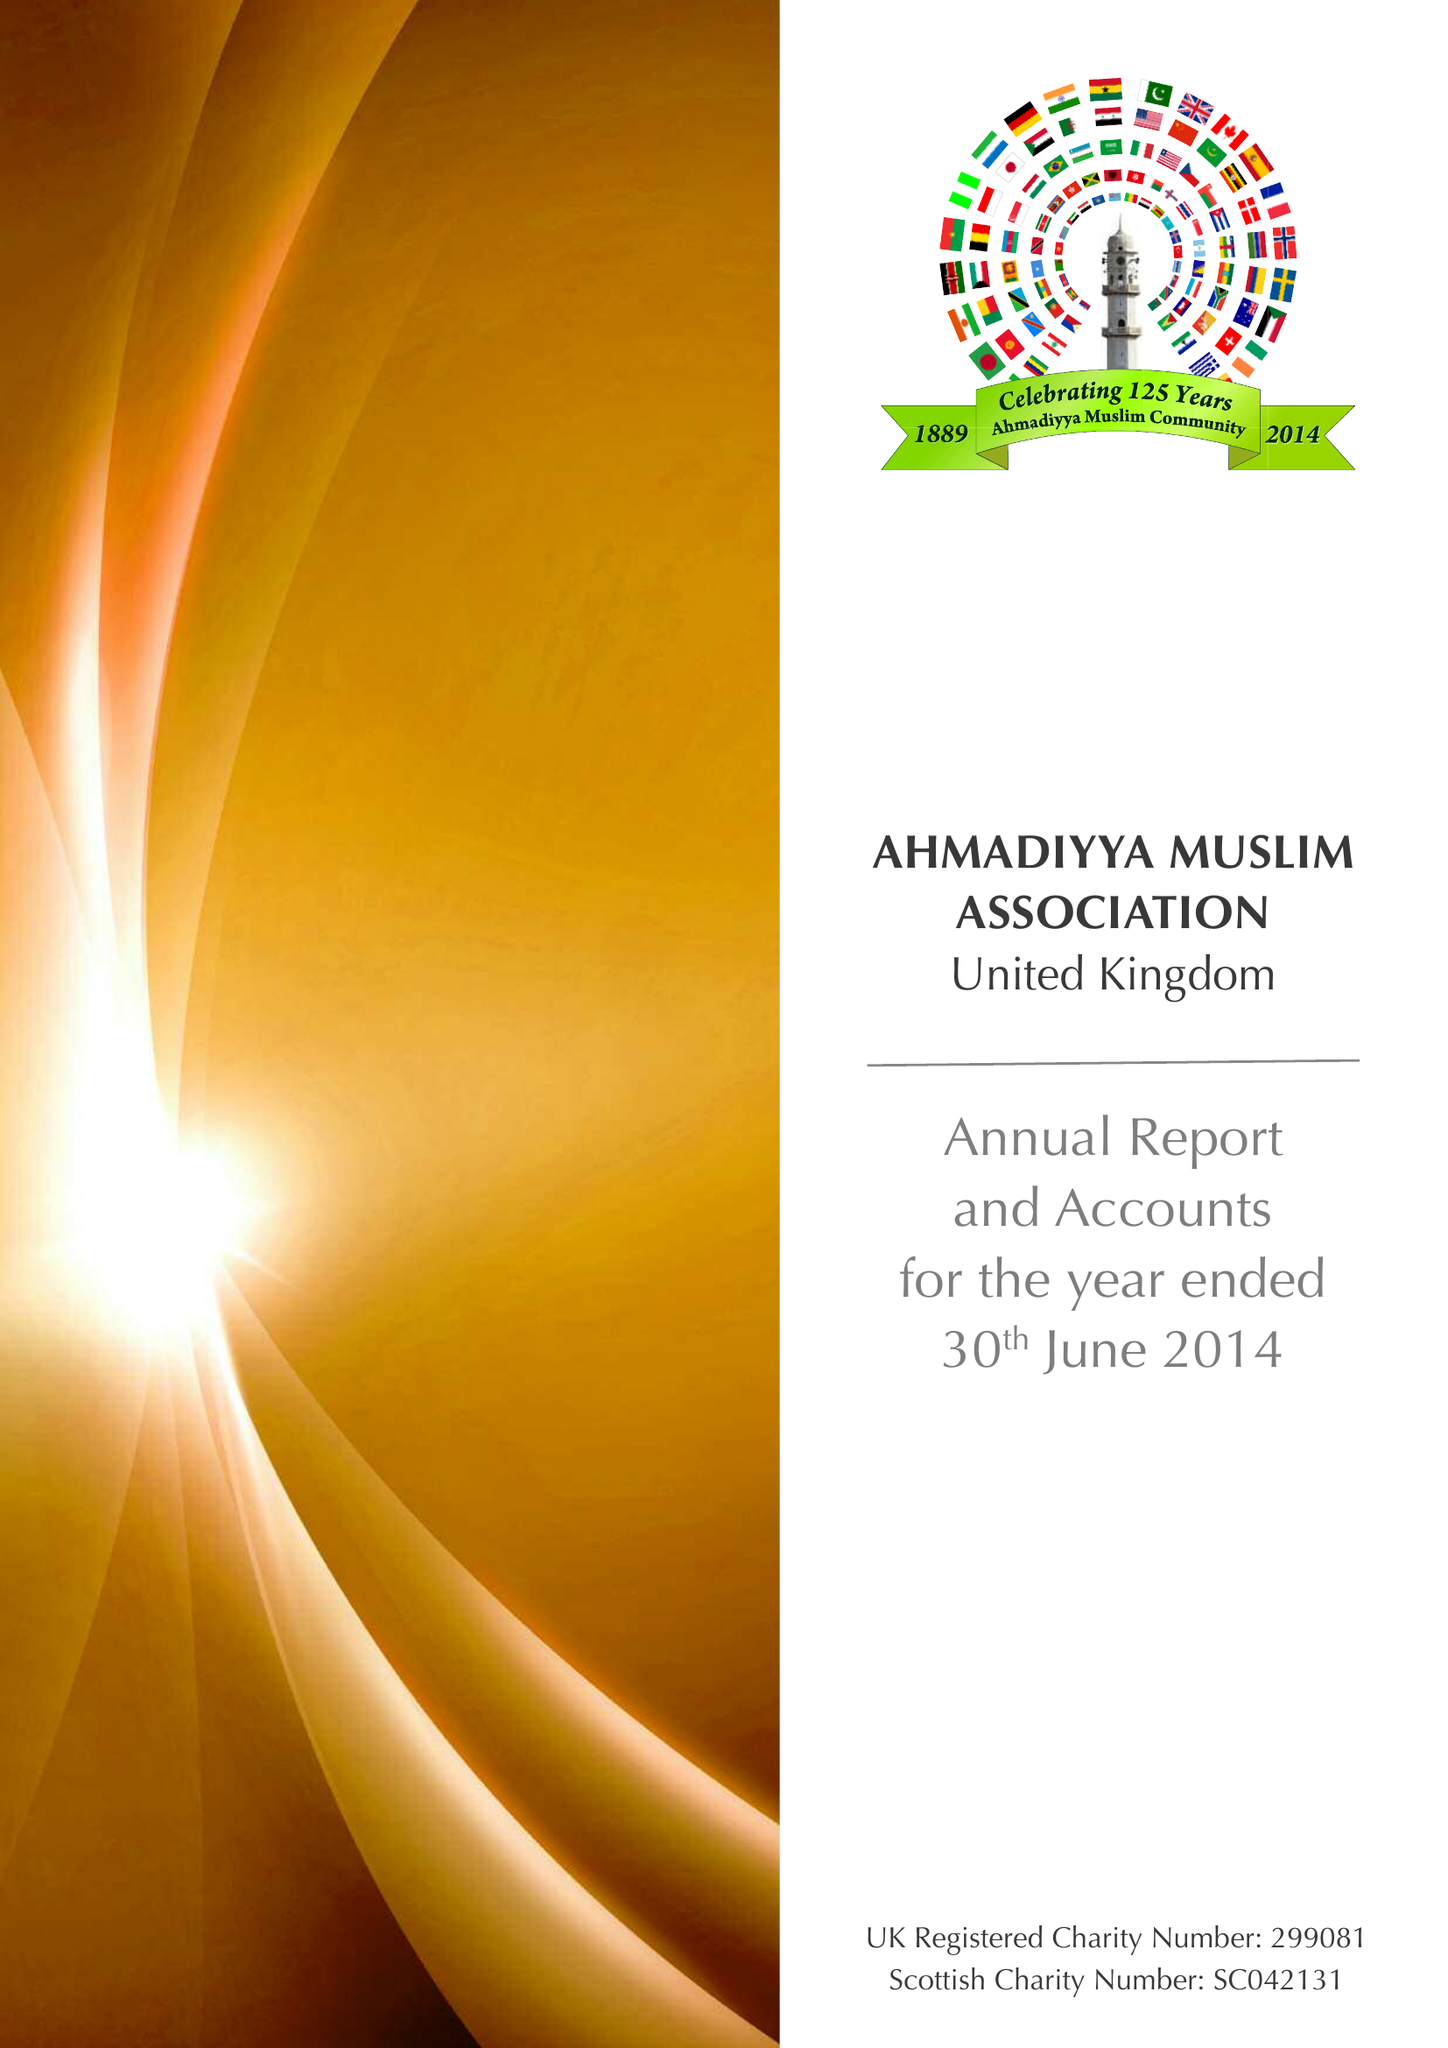What is the value for the address__postcode?
Answer the question using a single word or phrase. SW18 1LX 